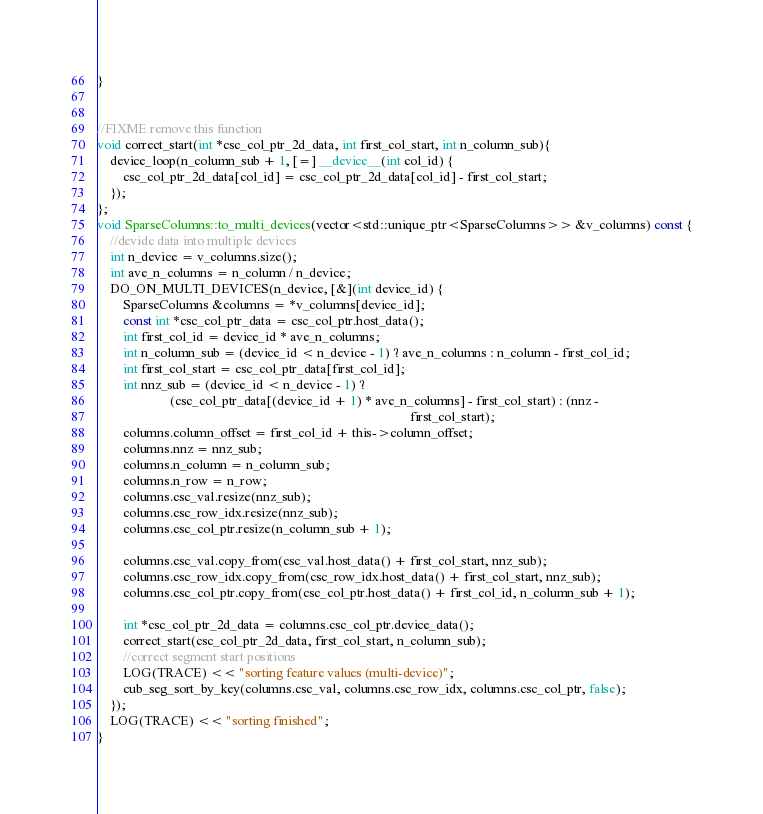Convert code to text. <code><loc_0><loc_0><loc_500><loc_500><_Cuda_>}


//FIXME remove this function
void correct_start(int *csc_col_ptr_2d_data, int first_col_start, int n_column_sub){
    device_loop(n_column_sub + 1, [=] __device__(int col_id) {
        csc_col_ptr_2d_data[col_id] = csc_col_ptr_2d_data[col_id] - first_col_start;
    });
};
void SparseColumns::to_multi_devices(vector<std::unique_ptr<SparseColumns>> &v_columns) const {
    //devide data into multiple devices
    int n_device = v_columns.size();
    int ave_n_columns = n_column / n_device;
    DO_ON_MULTI_DEVICES(n_device, [&](int device_id) {
        SparseColumns &columns = *v_columns[device_id];
        const int *csc_col_ptr_data = csc_col_ptr.host_data();
        int first_col_id = device_id * ave_n_columns;
        int n_column_sub = (device_id < n_device - 1) ? ave_n_columns : n_column - first_col_id;
        int first_col_start = csc_col_ptr_data[first_col_id];
        int nnz_sub = (device_id < n_device - 1) ?
                      (csc_col_ptr_data[(device_id + 1) * ave_n_columns] - first_col_start) : (nnz -
                                                                                               first_col_start);
        columns.column_offset = first_col_id + this->column_offset;
        columns.nnz = nnz_sub;
        columns.n_column = n_column_sub;
        columns.n_row = n_row;
        columns.csc_val.resize(nnz_sub);
        columns.csc_row_idx.resize(nnz_sub);
        columns.csc_col_ptr.resize(n_column_sub + 1);

        columns.csc_val.copy_from(csc_val.host_data() + first_col_start, nnz_sub);
        columns.csc_row_idx.copy_from(csc_row_idx.host_data() + first_col_start, nnz_sub);
        columns.csc_col_ptr.copy_from(csc_col_ptr.host_data() + first_col_id, n_column_sub + 1);

        int *csc_col_ptr_2d_data = columns.csc_col_ptr.device_data();
        correct_start(csc_col_ptr_2d_data, first_col_start, n_column_sub);
        //correct segment start positions
        LOG(TRACE) << "sorting feature values (multi-device)";
        cub_seg_sort_by_key(columns.csc_val, columns.csc_row_idx, columns.csc_col_ptr, false);
    });
    LOG(TRACE) << "sorting finished";
}

</code> 